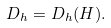Convert formula to latex. <formula><loc_0><loc_0><loc_500><loc_500>D _ { h } = D _ { h } ( H ) .</formula> 